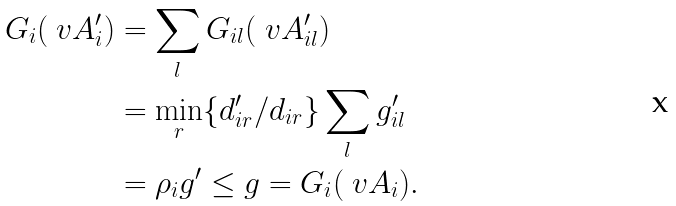Convert formula to latex. <formula><loc_0><loc_0><loc_500><loc_500>G _ { i } ( \ v A ^ { \prime } _ { i } ) & = \sum _ { l } G _ { i l } ( \ v A ^ { \prime } _ { i l } ) \\ & = \min _ { r } \{ d ^ { \prime } _ { i r } / d _ { i r } \} \sum _ { l } g ^ { \prime } _ { i l } \\ & = \rho _ { i } g ^ { \prime } \leq g = G _ { i } ( \ v A _ { i } ) .</formula> 